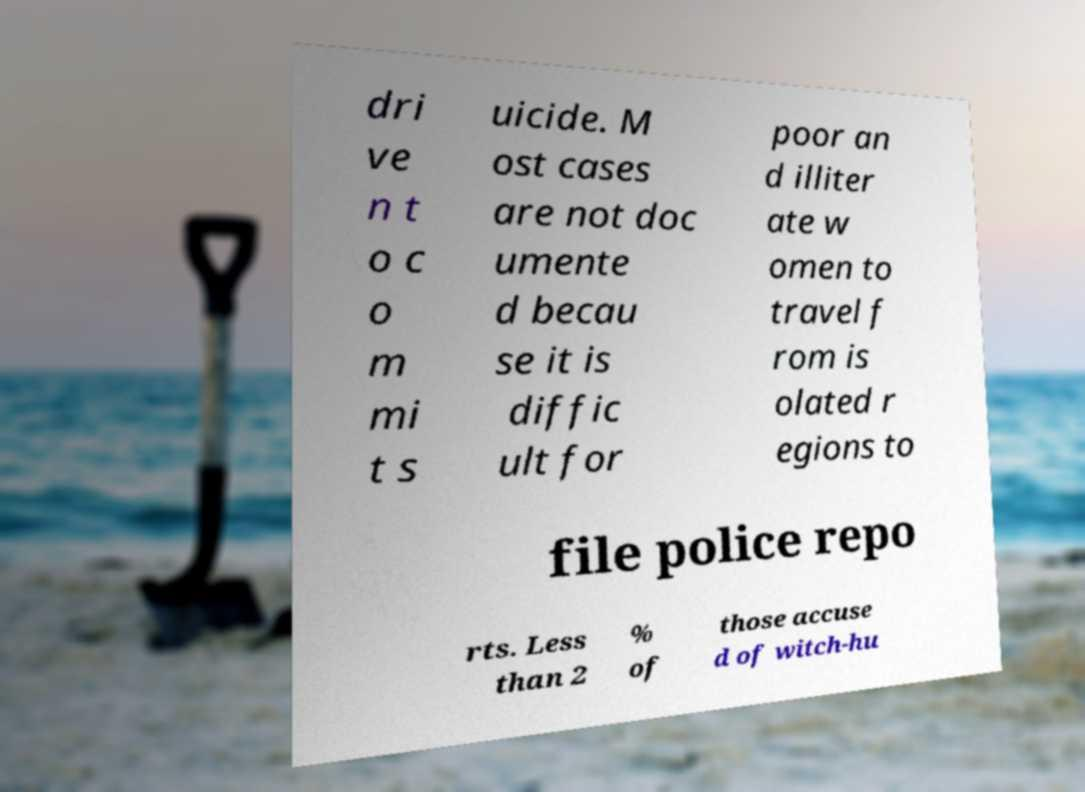Can you read and provide the text displayed in the image?This photo seems to have some interesting text. Can you extract and type it out for me? dri ve n t o c o m mi t s uicide. M ost cases are not doc umente d becau se it is diffic ult for poor an d illiter ate w omen to travel f rom is olated r egions to file police repo rts. Less than 2 % of those accuse d of witch-hu 